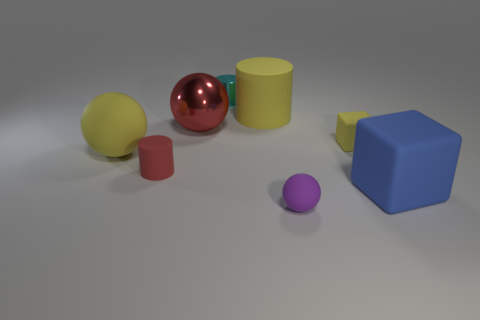How many objects are both right of the red matte thing and behind the tiny purple object? Upon examining the image, there appear to be no objects that are both to the right of the red object, which is spherical, and behind the tiny purple object, which seems to be a small purple ball. The spatial arrangement doesn't match the criteria given in the question. 